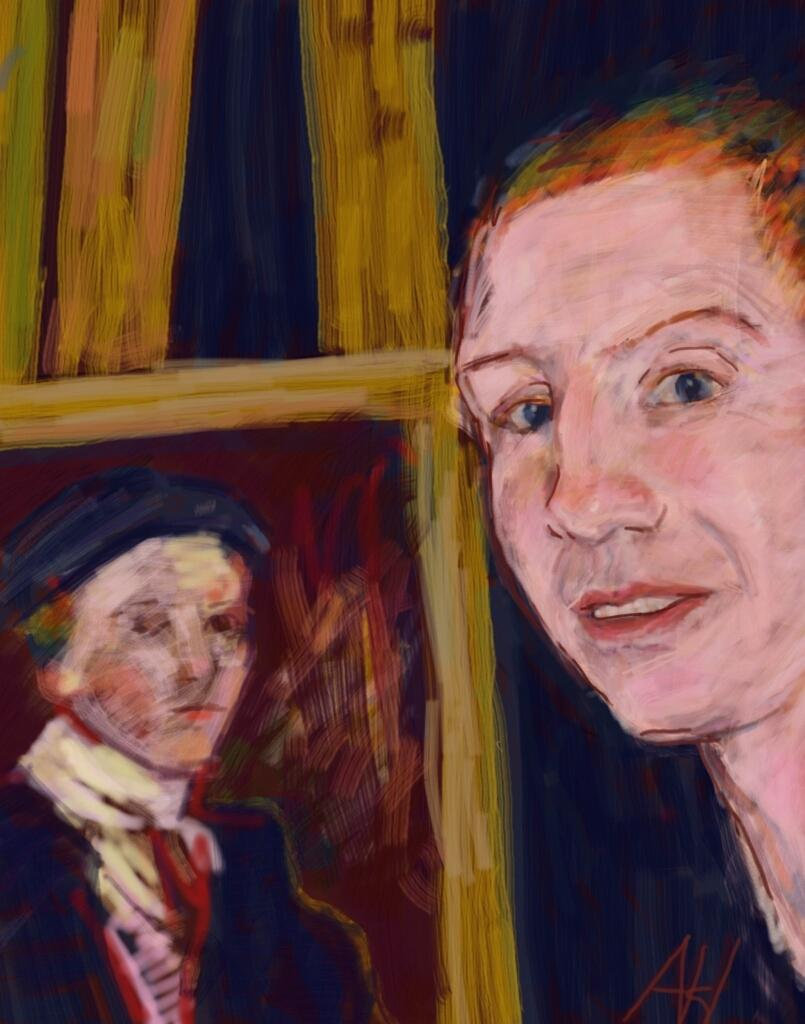How many people are present in the image? There are two people in the image. Can you describe the background of the image? There are bamboo poles in the background of the image. What type of metal is the trick being performed with in the image? There is no trick being performed in the image, and no metal is mentioned or visible. 